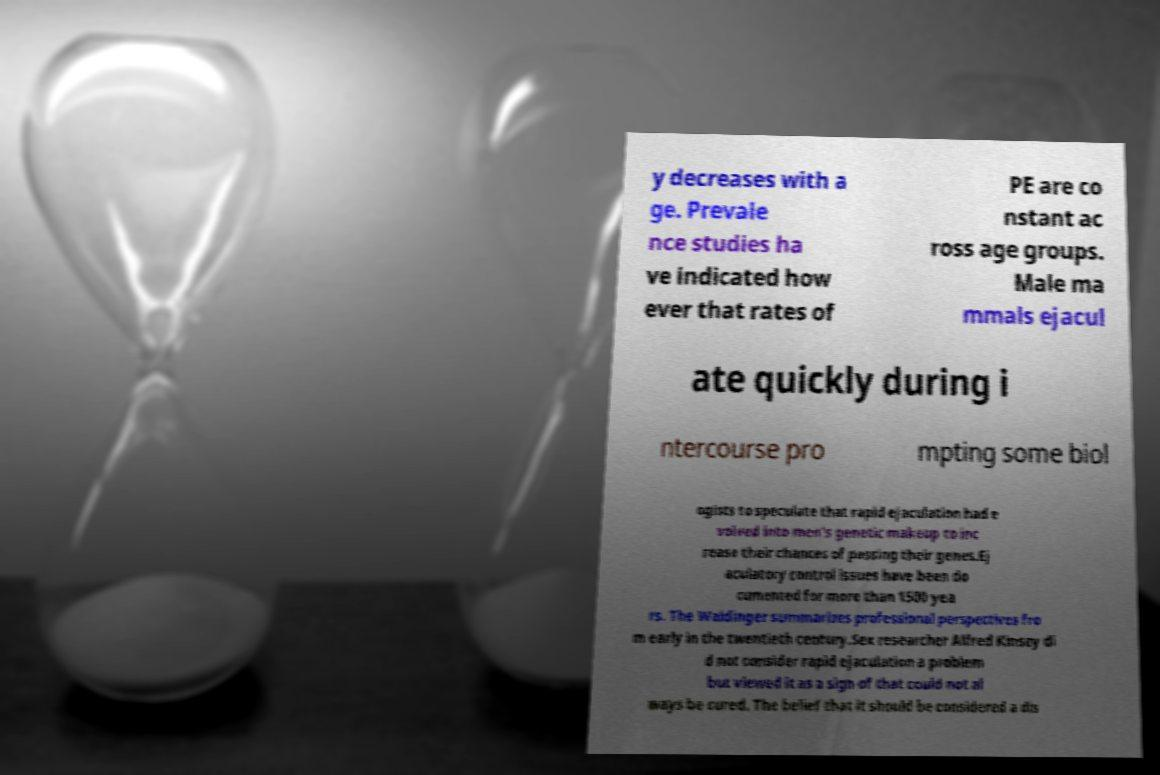Could you assist in decoding the text presented in this image and type it out clearly? y decreases with a ge. Prevale nce studies ha ve indicated how ever that rates of PE are co nstant ac ross age groups. Male ma mmals ejacul ate quickly during i ntercourse pro mpting some biol ogists to speculate that rapid ejaculation had e volved into men's genetic makeup to inc rease their chances of passing their genes.Ej aculatory control issues have been do cumented for more than 1500 yea rs. The Waldinger summarizes professional perspectives fro m early in the twentieth century.Sex researcher Alfred Kinsey di d not consider rapid ejaculation a problem but viewed it as a sign of that could not al ways be cured. The belief that it should be considered a dis 